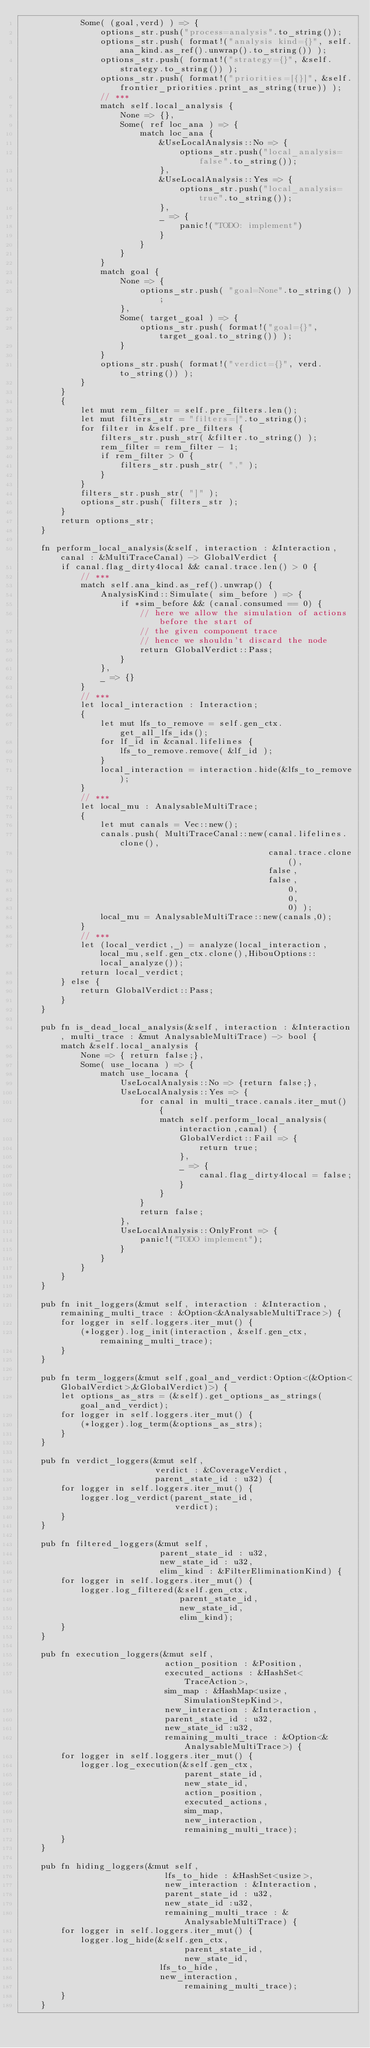<code> <loc_0><loc_0><loc_500><loc_500><_Rust_>            Some( (goal,verd) ) => {
                options_str.push("process=analysis".to_string());
                options_str.push( format!("analysis kind={}", self.ana_kind.as_ref().unwrap().to_string()) );
                options_str.push( format!("strategy={}", &self.strategy.to_string()) );
                options_str.push( format!("priorities=[{}]", &self.frontier_priorities.print_as_string(true)) );
                // ***
                match self.local_analysis {
                    None => {},
                    Some( ref loc_ana ) => {
                        match loc_ana {
                            &UseLocalAnalysis::No => {
                                options_str.push("local_analysis=false".to_string());
                            },
                            &UseLocalAnalysis::Yes => {
                                options_str.push("local_analysis=true".to_string());
                            },
                            _ => {
                                panic!("TODO: implement")
                            }
                        }
                    }
                }
                match goal {
                    None => {
                        options_str.push( "goal=None".to_string() );
                    },
                    Some( target_goal ) => {
                        options_str.push( format!("goal={}", target_goal.to_string()) );
                    }
                }
                options_str.push( format!("verdict={}", verd.to_string()) );
            }
        }
        {
            let mut rem_filter = self.pre_filters.len();
            let mut filters_str = "filters=[".to_string();
            for filter in &self.pre_filters {
                filters_str.push_str( &filter.to_string() );
                rem_filter = rem_filter - 1;
                if rem_filter > 0 {
                    filters_str.push_str( "," );
                }
            }
            filters_str.push_str( "]" );
            options_str.push( filters_str );
        }
        return options_str;
    }

    fn perform_local_analysis(&self, interaction : &Interaction, canal : &MultiTraceCanal) -> GlobalVerdict {
        if canal.flag_dirty4local && canal.trace.len() > 0 {
            // ***
            match self.ana_kind.as_ref().unwrap() {
                AnalysisKind::Simulate( sim_before ) => {
                    if *sim_before && (canal.consumed == 0) {
                        // here we allow the simulation of actions before the start of
                        // the given component trace
                        // hence we shouldn't discard the node
                        return GlobalVerdict::Pass;
                    }
                },
                _ => {}
            }
            // ***
            let local_interaction : Interaction;
            {
                let mut lfs_to_remove = self.gen_ctx.get_all_lfs_ids();
                for lf_id in &canal.lifelines {
                    lfs_to_remove.remove( &lf_id );
                }
                local_interaction = interaction.hide(&lfs_to_remove);
            }
            // ***
            let local_mu : AnalysableMultiTrace;
            {
                let mut canals = Vec::new();
                canals.push( MultiTraceCanal::new(canal.lifelines.clone(),
                                                  canal.trace.clone(),
                                                  false,
                                                  false,
                                                      0,
                                                      0,
                                                      0) );
                local_mu = AnalysableMultiTrace::new(canals,0);
            }
            // ***
            let (local_verdict,_) = analyze(local_interaction,local_mu,self.gen_ctx.clone(),HibouOptions::local_analyze());
            return local_verdict;
        } else {
            return GlobalVerdict::Pass;
        }
    }

    pub fn is_dead_local_analysis(&self, interaction : &Interaction, multi_trace : &mut AnalysableMultiTrace) -> bool {
        match &self.local_analysis {
            None => { return false;},
            Some( use_locana ) => {
                match use_locana {
                    UseLocalAnalysis::No => {return false;},
                    UseLocalAnalysis::Yes => {
                        for canal in multi_trace.canals.iter_mut() {
                            match self.perform_local_analysis(interaction,canal) {
                                GlobalVerdict::Fail => {
                                    return true;
                                },
                                _ => {
                                    canal.flag_dirty4local = false;
                                }
                            }
                        }
                        return false;
                    },
                    UseLocalAnalysis::OnlyFront => {
                        panic!("TODO implement");
                    }
                }
            }
        }
    }

    pub fn init_loggers(&mut self, interaction : &Interaction,remaining_multi_trace : &Option<&AnalysableMultiTrace>) {
        for logger in self.loggers.iter_mut() {
            (*logger).log_init(interaction, &self.gen_ctx, remaining_multi_trace);
        }
    }

    pub fn term_loggers(&mut self,goal_and_verdict:Option<(&Option<GlobalVerdict>,&GlobalVerdict)>) {
        let options_as_strs = (&self).get_options_as_strings(goal_and_verdict);
        for logger in self.loggers.iter_mut() {
            (*logger).log_term(&options_as_strs);
        }
    }

    pub fn verdict_loggers(&mut self,
                           verdict : &CoverageVerdict,
                           parent_state_id : u32) {
        for logger in self.loggers.iter_mut() {
            logger.log_verdict(parent_state_id,
                               verdict);
        }
    }

    pub fn filtered_loggers(&mut self,
                            parent_state_id : u32,
                            new_state_id : u32,
                            elim_kind : &FilterEliminationKind) {
        for logger in self.loggers.iter_mut() {
            logger.log_filtered(&self.gen_ctx,
                                parent_state_id,
                                new_state_id,
                                elim_kind);
        }
    }

    pub fn execution_loggers(&mut self,
                             action_position : &Position,
                             executed_actions : &HashSet<TraceAction>,
                             sim_map : &HashMap<usize,SimulationStepKind>,
                             new_interaction : &Interaction,
                             parent_state_id : u32,
                             new_state_id :u32,
                             remaining_multi_trace : &Option<&AnalysableMultiTrace>) {
        for logger in self.loggers.iter_mut() {
            logger.log_execution(&self.gen_ctx,
                                 parent_state_id,
                                 new_state_id,
                                 action_position,
                                 executed_actions,
                                 sim_map,
                                 new_interaction,
                                 remaining_multi_trace);
        }
    }

    pub fn hiding_loggers(&mut self,
                             lfs_to_hide : &HashSet<usize>,
                             new_interaction : &Interaction,
                             parent_state_id : u32,
                             new_state_id :u32,
                             remaining_multi_trace : &AnalysableMultiTrace) {
        for logger in self.loggers.iter_mut() {
            logger.log_hide(&self.gen_ctx,
                                 parent_state_id,
                                 new_state_id,
                            lfs_to_hide,
                            new_interaction,
                                 remaining_multi_trace);
        }
    }
</code> 